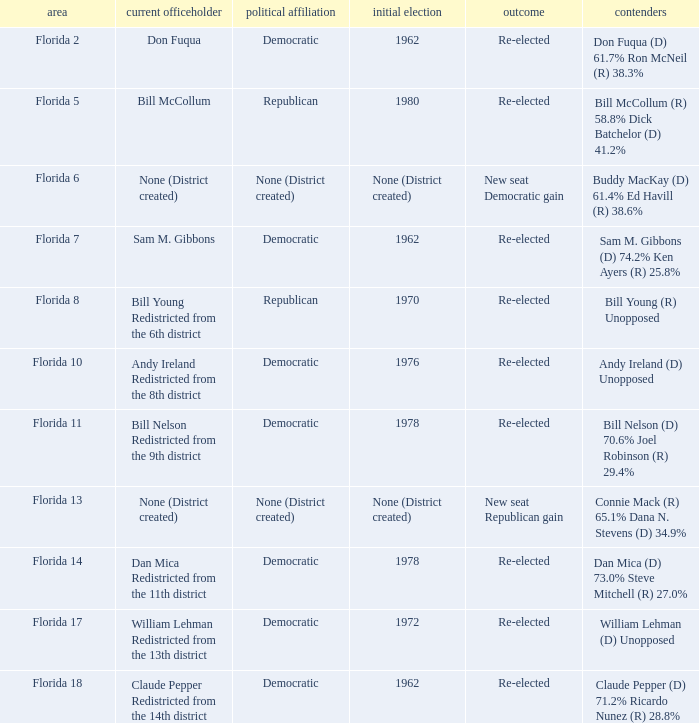What's the district with result being new seat democratic gain Florida 6. 